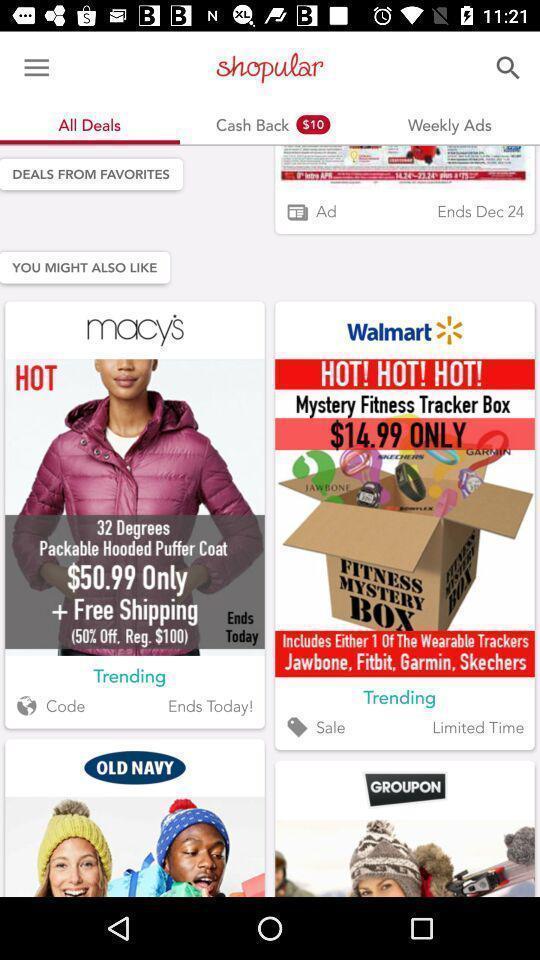Describe the visual elements of this screenshot. Page showing search bar to find different products. 